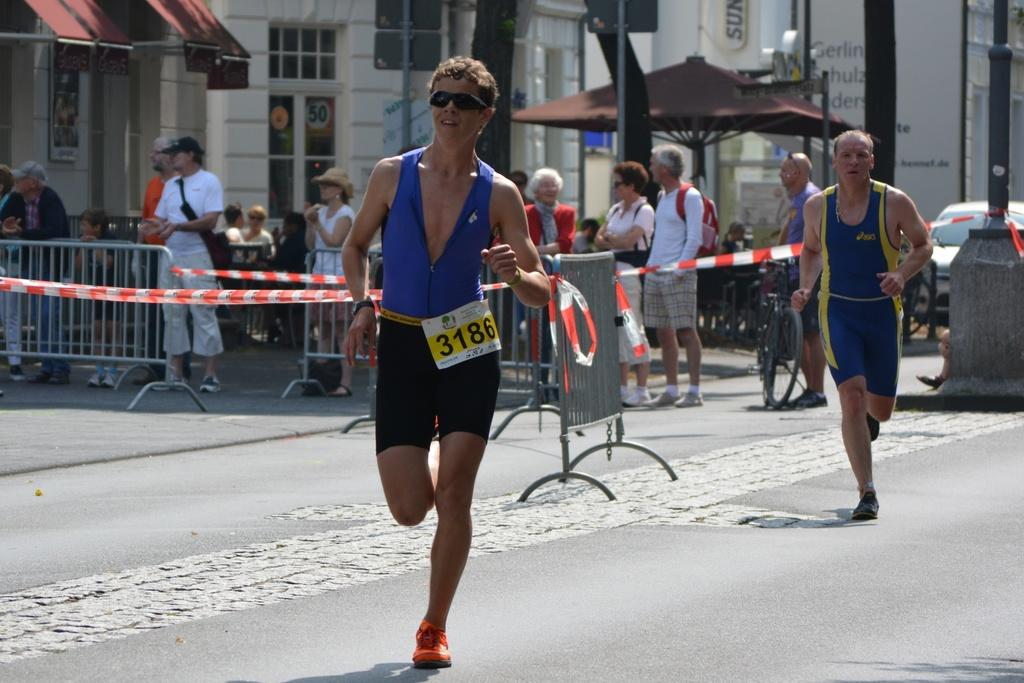What are the two persons in the image doing? The two persons in the image are running. Where are the running persons located? The running persons are on a road. What can be seen in the background of the image? There are people, trees, and a vehicle in the background of the image. What type of insurance policy do the trees in the background have? There is no information about insurance policies for the trees in the image, as they are not the focus of the image. 